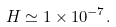<formula> <loc_0><loc_0><loc_500><loc_500>H \simeq 1 \times 1 0 ^ { - 7 } .</formula> 